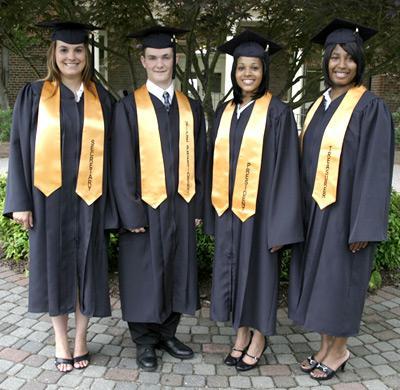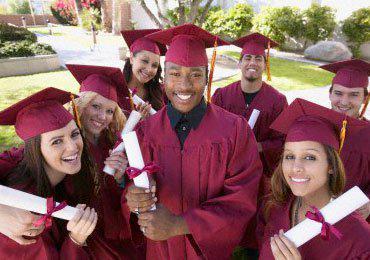The first image is the image on the left, the second image is the image on the right. Evaluate the accuracy of this statement regarding the images: "All graduates in each image are wearing identical gowns and sashes.". Is it true? Answer yes or no. Yes. 